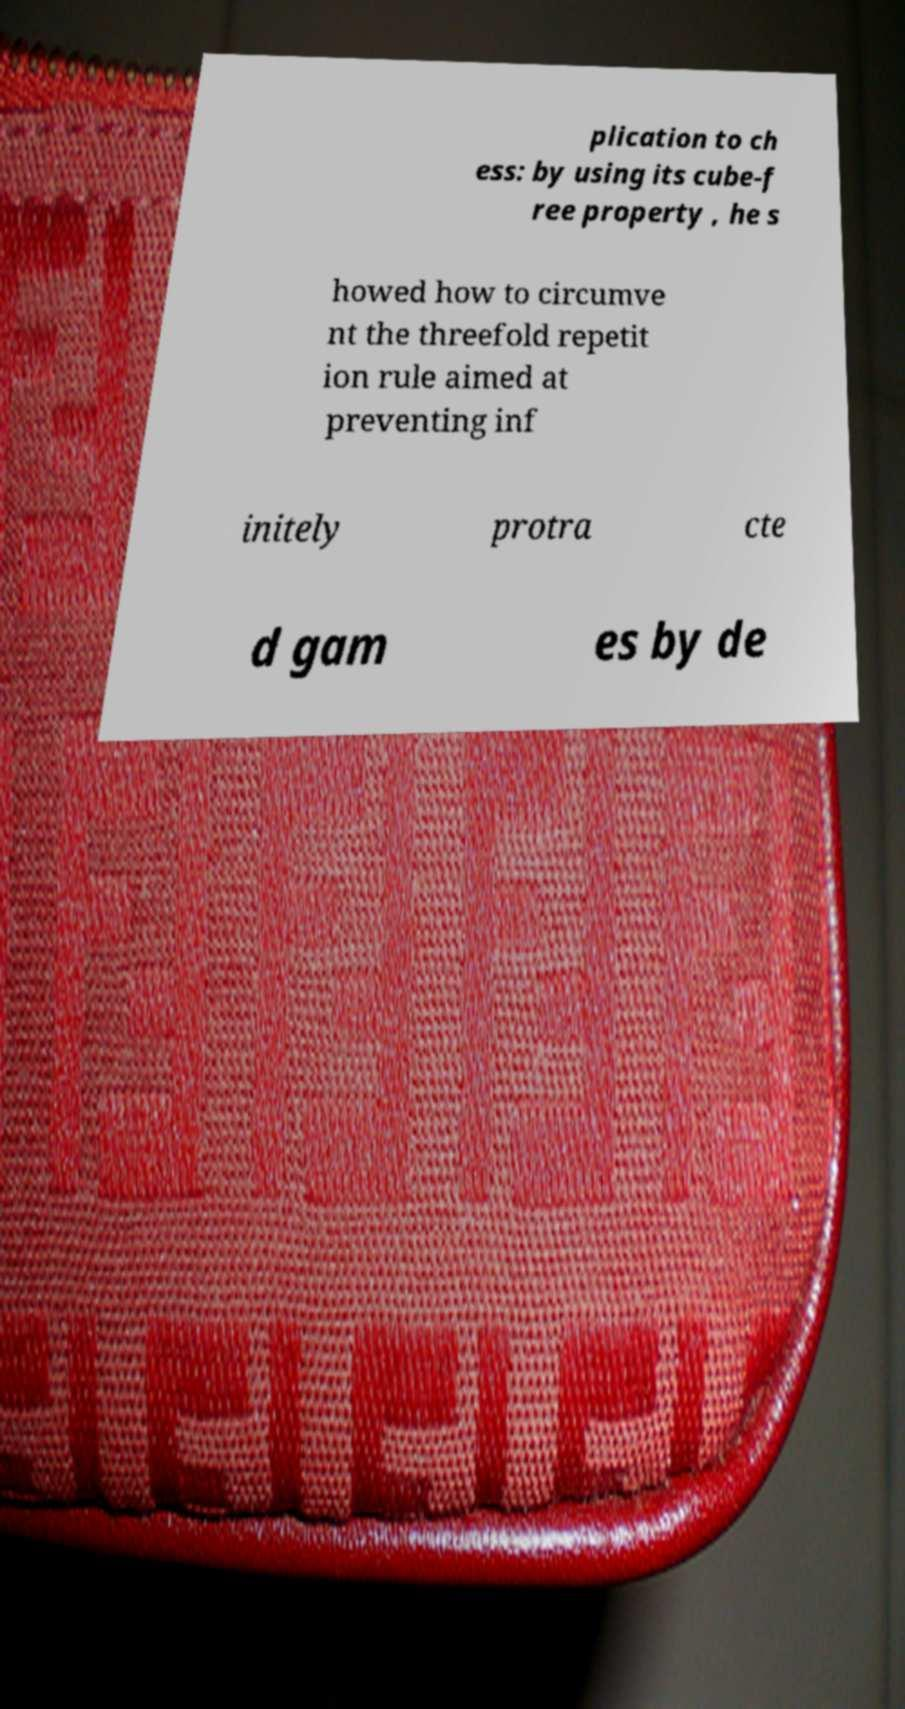For documentation purposes, I need the text within this image transcribed. Could you provide that? plication to ch ess: by using its cube-f ree property , he s howed how to circumve nt the threefold repetit ion rule aimed at preventing inf initely protra cte d gam es by de 